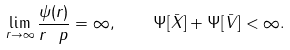Convert formula to latex. <formula><loc_0><loc_0><loc_500><loc_500>\lim _ { r \rightarrow \infty } \frac { \psi ( r ) } { r ^ { \ } p } = \infty , \quad \Psi [ \bar { X } ] + \Psi [ \bar { V } ] < \infty .</formula> 